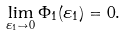<formula> <loc_0><loc_0><loc_500><loc_500>\lim _ { \varepsilon _ { 1 } \to 0 } \Phi _ { 1 } ( \varepsilon _ { 1 } ) = 0 .</formula> 